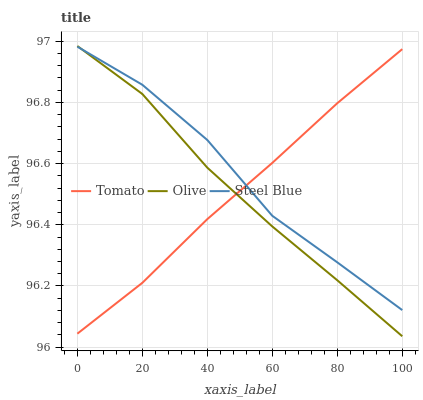Does Tomato have the minimum area under the curve?
Answer yes or no. Yes. Does Steel Blue have the maximum area under the curve?
Answer yes or no. Yes. Does Olive have the minimum area under the curve?
Answer yes or no. No. Does Olive have the maximum area under the curve?
Answer yes or no. No. Is Tomato the smoothest?
Answer yes or no. Yes. Is Steel Blue the roughest?
Answer yes or no. Yes. Is Olive the smoothest?
Answer yes or no. No. Is Olive the roughest?
Answer yes or no. No. Does Olive have the lowest value?
Answer yes or no. Yes. Does Steel Blue have the lowest value?
Answer yes or no. No. Does Olive have the highest value?
Answer yes or no. Yes. Does Steel Blue have the highest value?
Answer yes or no. No. Does Olive intersect Tomato?
Answer yes or no. Yes. Is Olive less than Tomato?
Answer yes or no. No. Is Olive greater than Tomato?
Answer yes or no. No. 